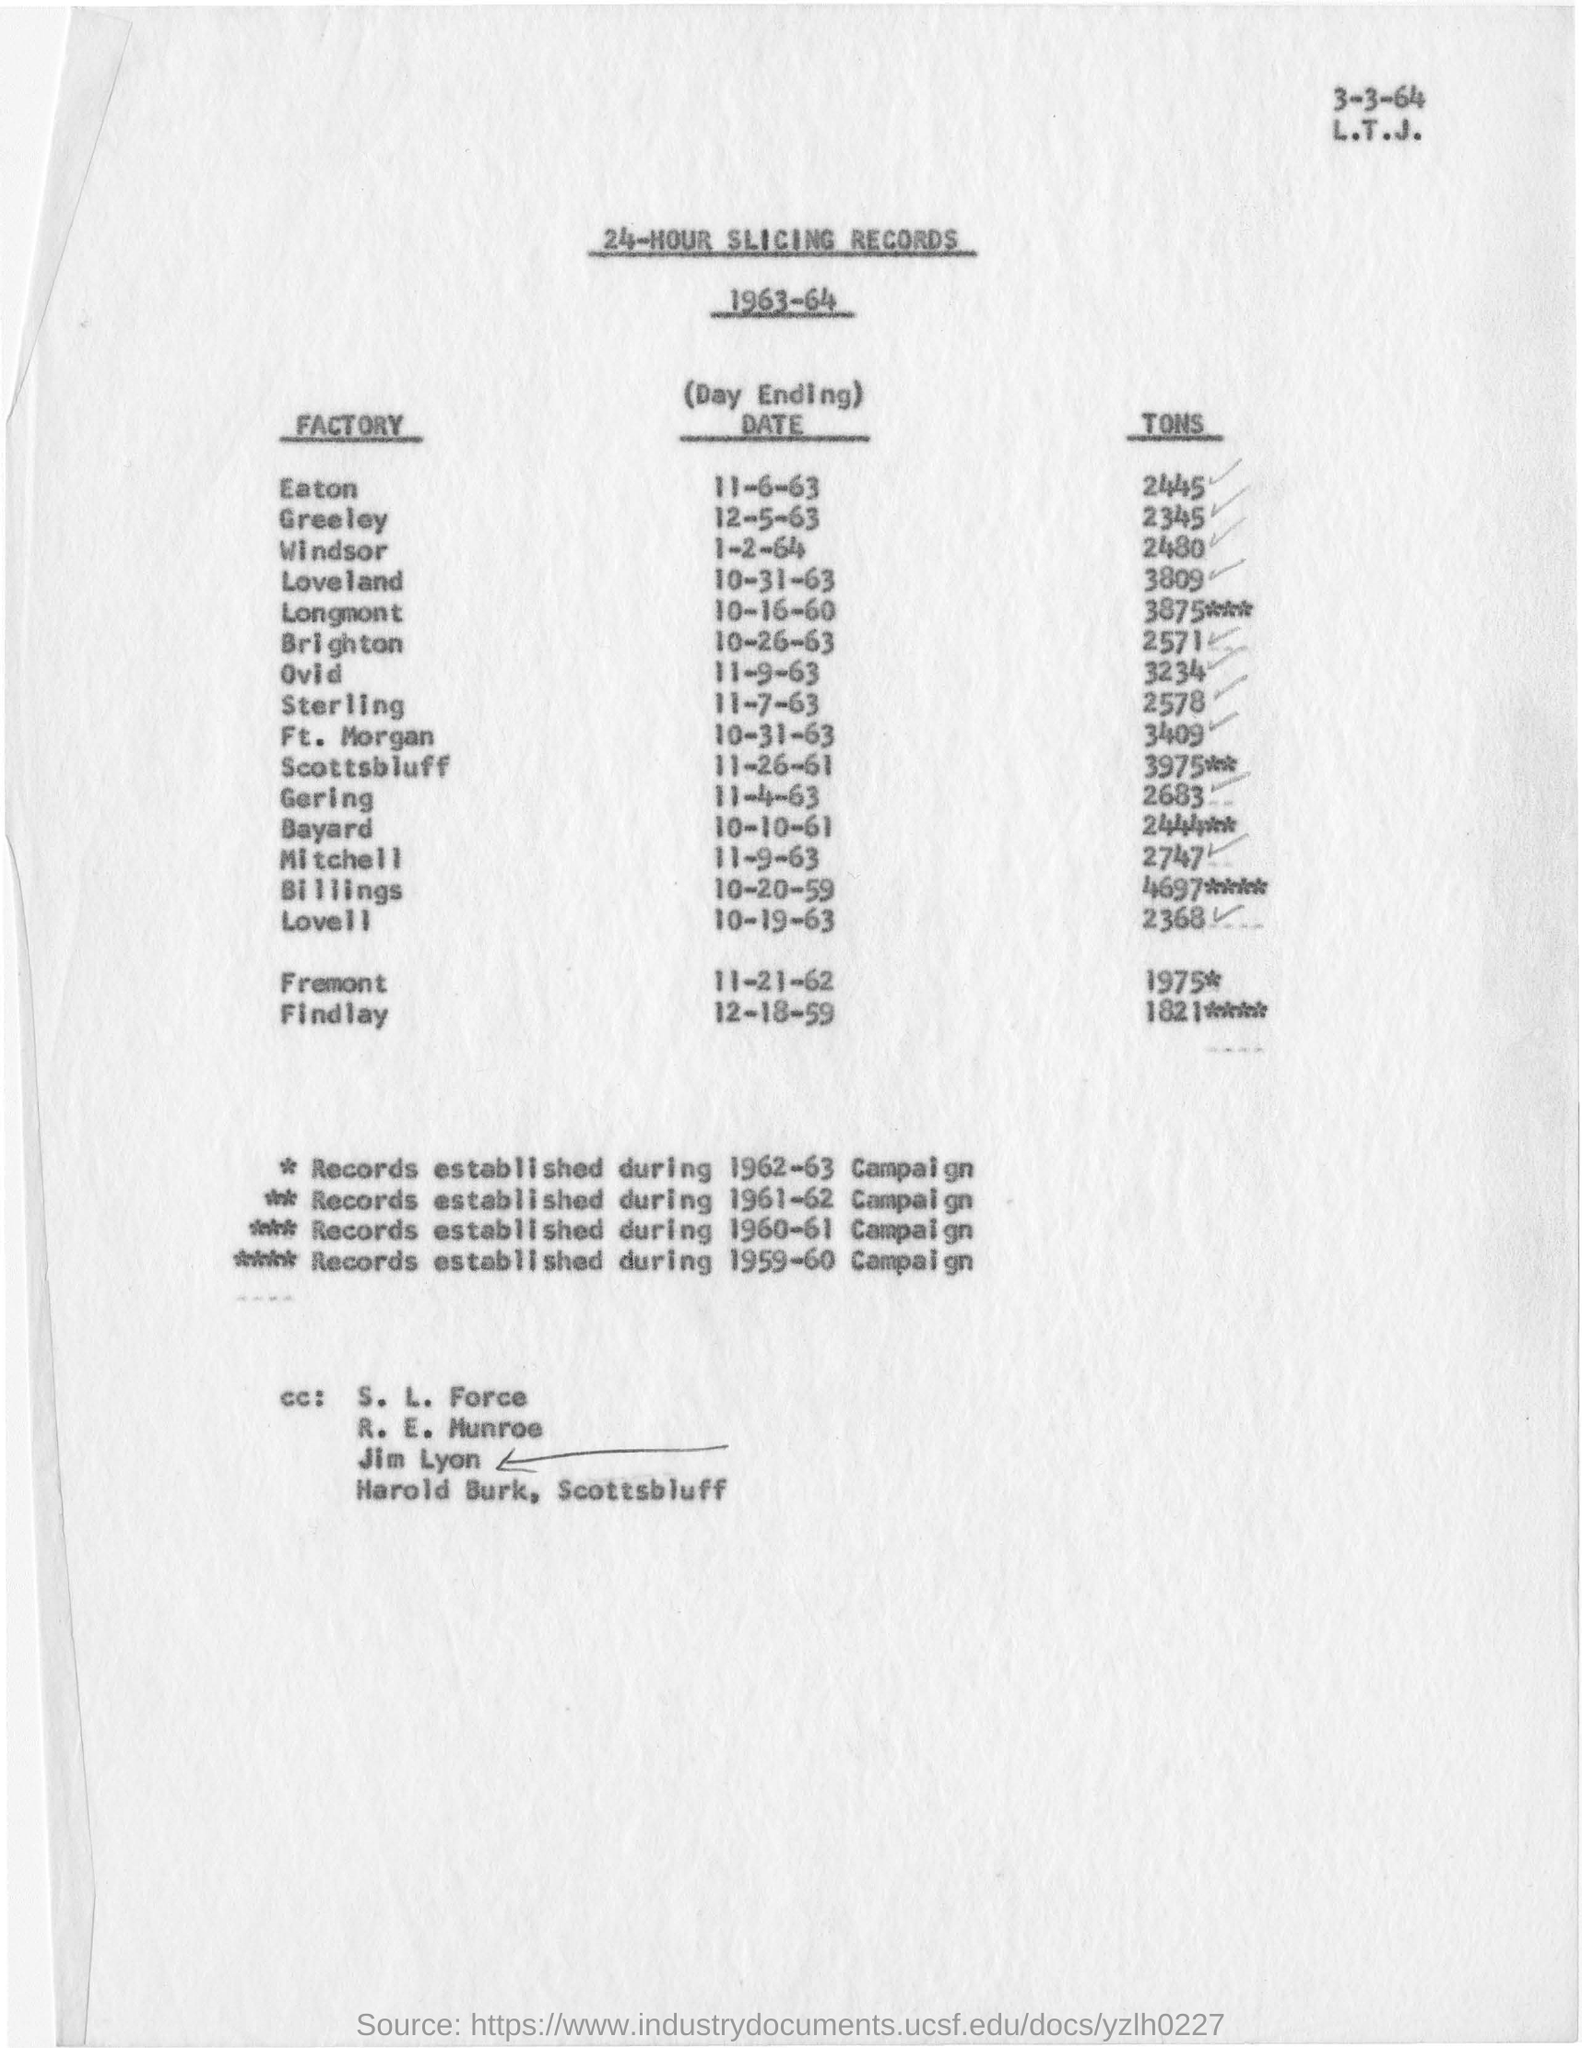What is date mentioned top of the page
Your response must be concise. 3-3--64. 